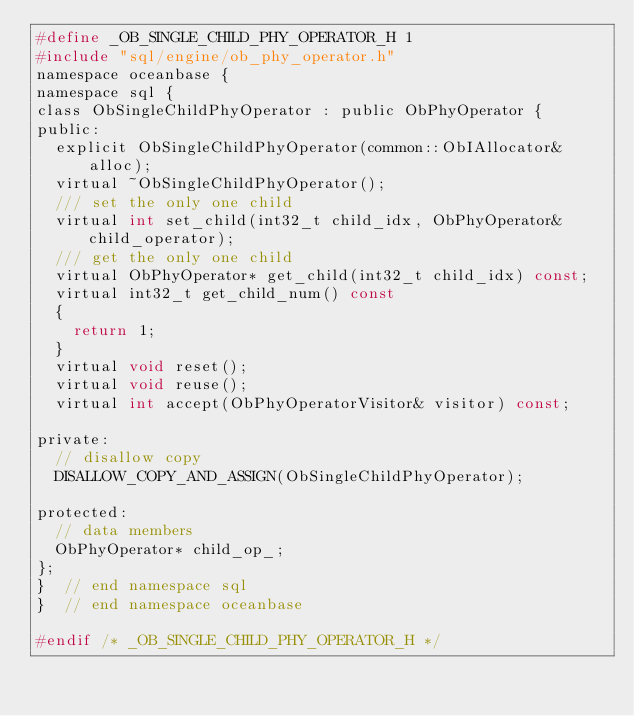Convert code to text. <code><loc_0><loc_0><loc_500><loc_500><_C_>#define _OB_SINGLE_CHILD_PHY_OPERATOR_H 1
#include "sql/engine/ob_phy_operator.h"
namespace oceanbase {
namespace sql {
class ObSingleChildPhyOperator : public ObPhyOperator {
public:
  explicit ObSingleChildPhyOperator(common::ObIAllocator& alloc);
  virtual ~ObSingleChildPhyOperator();
  /// set the only one child
  virtual int set_child(int32_t child_idx, ObPhyOperator& child_operator);
  /// get the only one child
  virtual ObPhyOperator* get_child(int32_t child_idx) const;
  virtual int32_t get_child_num() const
  {
    return 1;
  }
  virtual void reset();
  virtual void reuse();
  virtual int accept(ObPhyOperatorVisitor& visitor) const;

private:
  // disallow copy
  DISALLOW_COPY_AND_ASSIGN(ObSingleChildPhyOperator);

protected:
  // data members
  ObPhyOperator* child_op_;
};
}  // end namespace sql
}  // end namespace oceanbase

#endif /* _OB_SINGLE_CHILD_PHY_OPERATOR_H */
</code> 